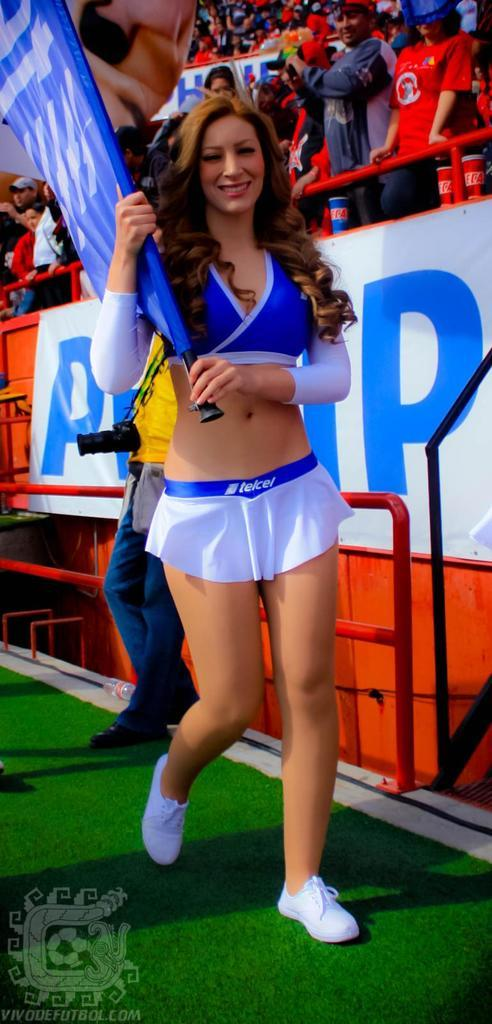<image>
Create a compact narrative representing the image presented. A woman is carrying a flag and her skirt advertises Telcel. 